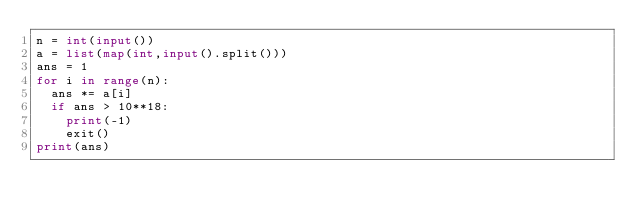<code> <loc_0><loc_0><loc_500><loc_500><_Python_>n = int(input())
a = list(map(int,input().split()))
ans = 1
for i in range(n):
  ans *= a[i]
  if ans > 10**18:
    print(-1)
    exit()
print(ans)</code> 